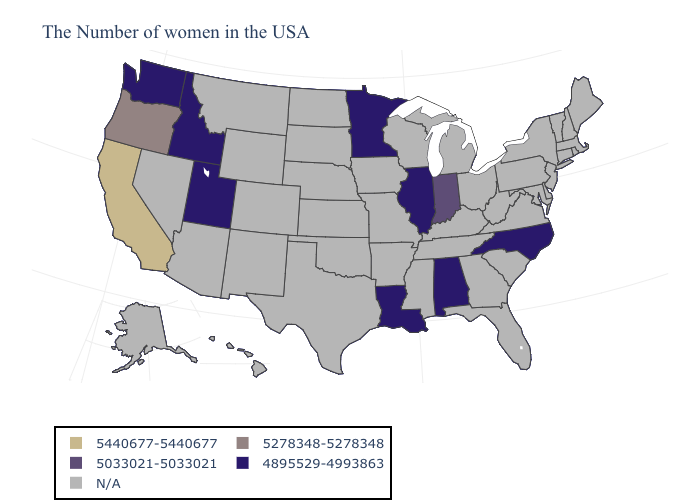Name the states that have a value in the range 5278348-5278348?
Write a very short answer. Oregon. What is the value of New Jersey?
Answer briefly. N/A. What is the highest value in the South ?
Write a very short answer. 4895529-4993863. Name the states that have a value in the range 5440677-5440677?
Answer briefly. California. Name the states that have a value in the range 4895529-4993863?
Write a very short answer. North Carolina, Alabama, Illinois, Louisiana, Minnesota, Utah, Idaho, Washington. Which states have the highest value in the USA?
Concise answer only. California. What is the value of Alabama?
Give a very brief answer. 4895529-4993863. What is the highest value in the MidWest ?
Keep it brief. 5033021-5033021. What is the highest value in the South ?
Answer briefly. 4895529-4993863. Which states have the lowest value in the South?
Quick response, please. North Carolina, Alabama, Louisiana. What is the value of Colorado?
Give a very brief answer. N/A. What is the highest value in the USA?
Be succinct. 5440677-5440677. Does the first symbol in the legend represent the smallest category?
Quick response, please. No. Name the states that have a value in the range 5033021-5033021?
Keep it brief. Indiana. What is the lowest value in the USA?
Concise answer only. 4895529-4993863. 